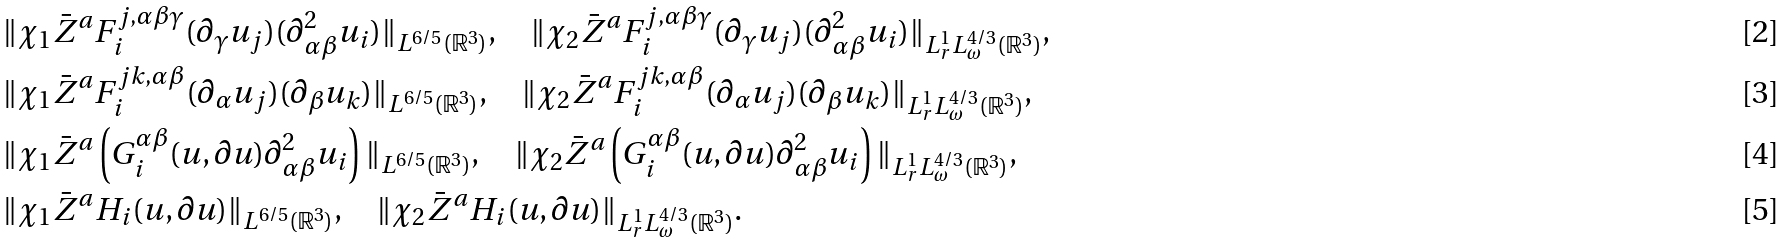Convert formula to latex. <formula><loc_0><loc_0><loc_500><loc_500>& \| \chi _ { 1 } { \bar { Z } } ^ { a } F _ { i } ^ { j , \alpha \beta \gamma } ( \partial _ { \gamma } u _ { j } ) ( \partial _ { \alpha \beta } ^ { 2 } u _ { i } ) \| _ { L ^ { 6 / 5 } ( { \mathbb { R } } ^ { 3 } ) } , \quad \| \chi _ { 2 } { \bar { Z } } ^ { a } F _ { i } ^ { j , \alpha \beta \gamma } ( \partial _ { \gamma } u _ { j } ) ( \partial _ { \alpha \beta } ^ { 2 } u _ { i } ) \| _ { L _ { r } ^ { 1 } L _ { \omega } ^ { 4 / 3 } ( { \mathbb { R } } ^ { 3 } ) } , \\ & \| \chi _ { 1 } { \bar { Z } } ^ { a } F _ { i } ^ { j k , \alpha \beta } ( \partial _ { \alpha } u _ { j } ) ( \partial _ { \beta } u _ { k } ) \| _ { L ^ { 6 / 5 } ( { \mathbb { R } } ^ { 3 } ) } , \quad \| \chi _ { 2 } { \bar { Z } } ^ { a } F _ { i } ^ { j k , \alpha \beta } ( \partial _ { \alpha } u _ { j } ) ( \partial _ { \beta } u _ { k } ) \| _ { L _ { r } ^ { 1 } L _ { \omega } ^ { 4 / 3 } ( { \mathbb { R } } ^ { 3 } ) } , \\ & \| \chi _ { 1 } { \bar { Z } } ^ { a } \left ( G _ { i } ^ { \alpha \beta } ( u , \partial u ) \partial _ { \alpha \beta } ^ { 2 } u _ { i } \right ) \| _ { L ^ { 6 / 5 } ( { \mathbb { R } } ^ { 3 } ) } , \quad \| \chi _ { 2 } { \bar { Z } } ^ { a } \left ( G _ { i } ^ { \alpha \beta } ( u , \partial u ) \partial _ { \alpha \beta } ^ { 2 } u _ { i } \right ) \| _ { L _ { r } ^ { 1 } L _ { \omega } ^ { 4 / 3 } ( { \mathbb { R } } ^ { 3 } ) } , \\ & \| \chi _ { 1 } { \bar { Z } } ^ { a } H _ { i } ( u , \partial u ) \| _ { L ^ { 6 / 5 } ( { \mathbb { R } } ^ { 3 } ) } , \quad \| \chi _ { 2 } { \bar { Z } } ^ { a } H _ { i } ( u , \partial u ) \| _ { L _ { r } ^ { 1 } L _ { \omega } ^ { 4 / 3 } ( { \mathbb { R } } ^ { 3 } ) } .</formula> 